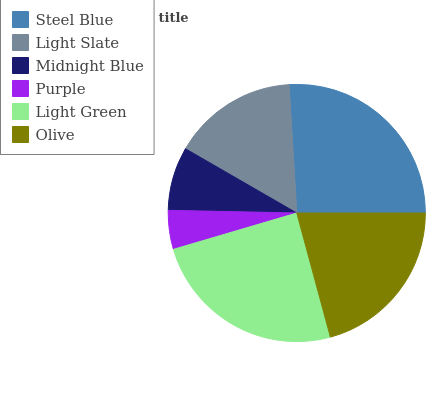Is Purple the minimum?
Answer yes or no. Yes. Is Steel Blue the maximum?
Answer yes or no. Yes. Is Light Slate the minimum?
Answer yes or no. No. Is Light Slate the maximum?
Answer yes or no. No. Is Steel Blue greater than Light Slate?
Answer yes or no. Yes. Is Light Slate less than Steel Blue?
Answer yes or no. Yes. Is Light Slate greater than Steel Blue?
Answer yes or no. No. Is Steel Blue less than Light Slate?
Answer yes or no. No. Is Olive the high median?
Answer yes or no. Yes. Is Light Slate the low median?
Answer yes or no. Yes. Is Light Slate the high median?
Answer yes or no. No. Is Light Green the low median?
Answer yes or no. No. 